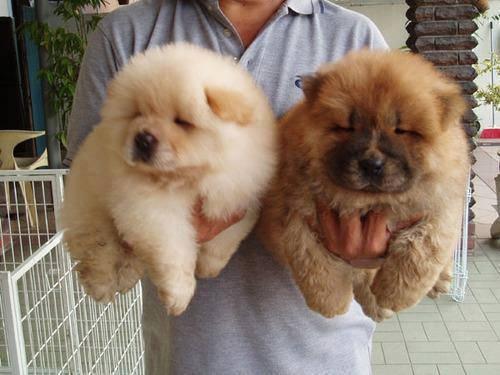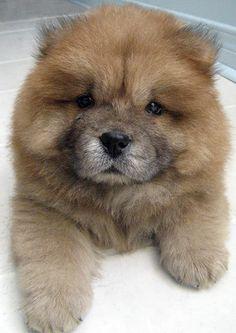The first image is the image on the left, the second image is the image on the right. Considering the images on both sides, is "One of the dogs is standing and looking toward the camera." valid? Answer yes or no. No. The first image is the image on the left, the second image is the image on the right. Given the left and right images, does the statement "A total of three dogs are shown in the foreground of the combined images." hold true? Answer yes or no. Yes. 